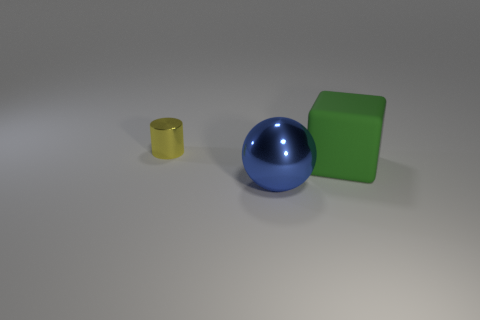Is there anything else that is the same size as the yellow metallic thing?
Offer a very short reply. No. How many other things are there of the same material as the small thing?
Make the answer very short. 1. There is a thing that is both on the left side of the matte object and behind the large blue ball; what color is it?
Keep it short and to the point. Yellow. What number of small yellow metallic cylinders are there?
Provide a succinct answer. 1. Do the blue thing and the yellow thing have the same size?
Offer a very short reply. No. What number of other blue metallic spheres are the same size as the shiny sphere?
Make the answer very short. 0. How many small yellow cylinders are behind the metallic thing that is in front of the rubber block?
Your answer should be compact. 1. Do the object that is behind the matte thing and the blue sphere have the same material?
Provide a short and direct response. Yes. Do the object that is to the left of the sphere and the large object behind the metal sphere have the same material?
Your answer should be very brief. No. Are there more cylinders on the left side of the yellow metal cylinder than green matte blocks?
Offer a very short reply. No. 